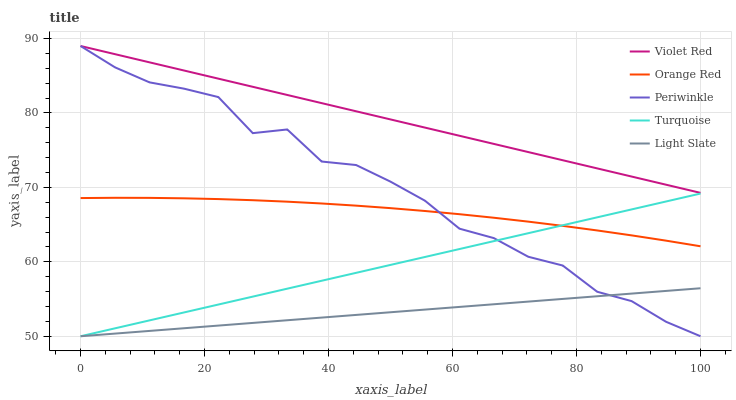Does Turquoise have the minimum area under the curve?
Answer yes or no. No. Does Turquoise have the maximum area under the curve?
Answer yes or no. No. Is Violet Red the smoothest?
Answer yes or no. No. Is Violet Red the roughest?
Answer yes or no. No. Does Violet Red have the lowest value?
Answer yes or no. No. Does Turquoise have the highest value?
Answer yes or no. No. Is Turquoise less than Violet Red?
Answer yes or no. Yes. Is Orange Red greater than Light Slate?
Answer yes or no. Yes. Does Turquoise intersect Violet Red?
Answer yes or no. No. 